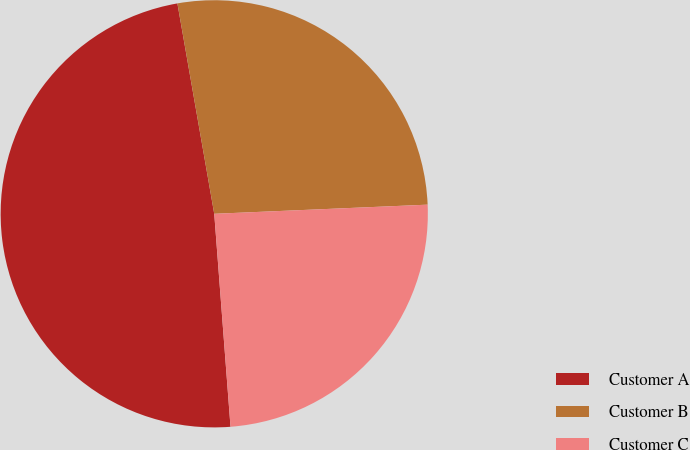<chart> <loc_0><loc_0><loc_500><loc_500><pie_chart><fcel>Customer A<fcel>Customer B<fcel>Customer C<nl><fcel>48.46%<fcel>27.08%<fcel>24.47%<nl></chart> 